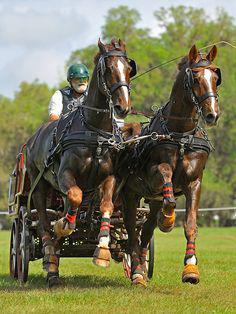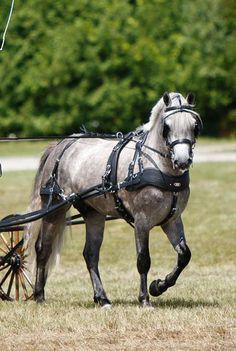The first image is the image on the left, the second image is the image on the right. Given the left and right images, does the statement "There are exactly three horses." hold true? Answer yes or no. Yes. The first image is the image on the left, the second image is the image on the right. Assess this claim about the two images: "A man in a helmet is being pulled by at least one horse.". Correct or not? Answer yes or no. Yes. 